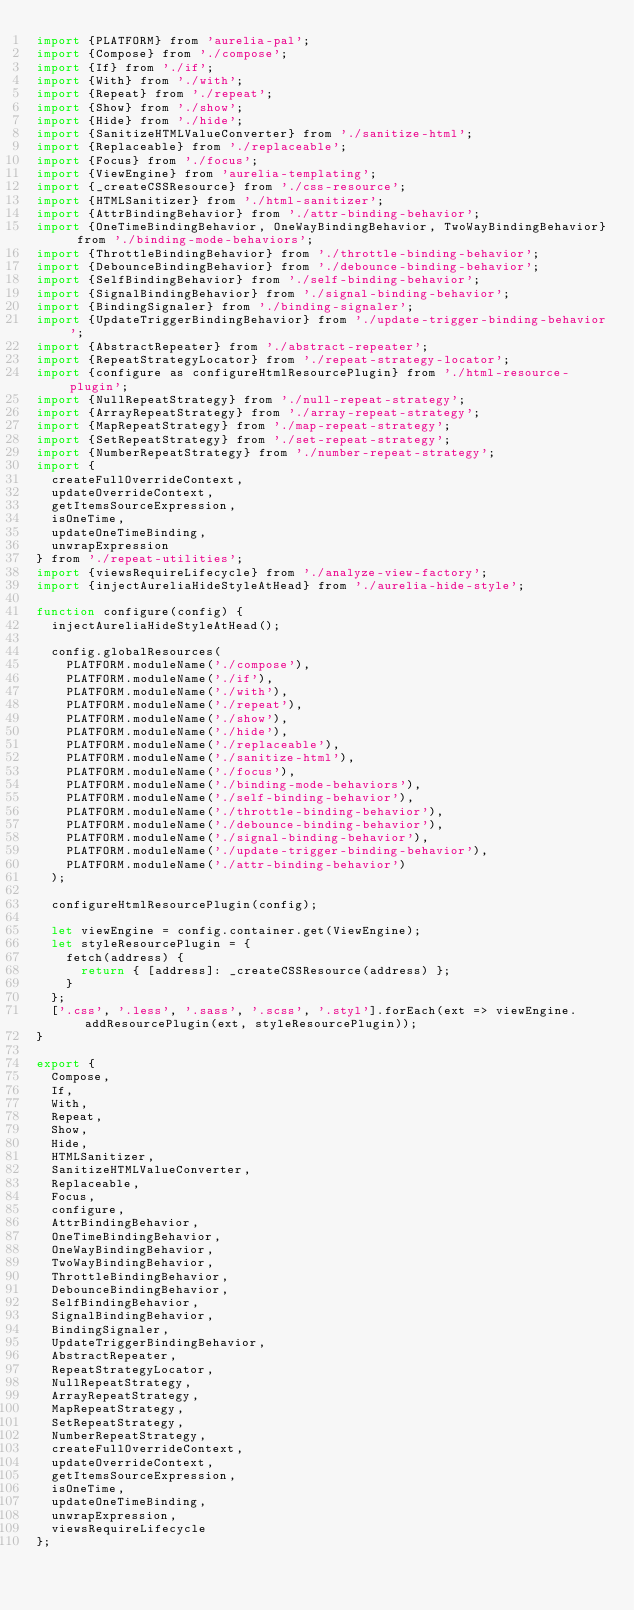Convert code to text. <code><loc_0><loc_0><loc_500><loc_500><_JavaScript_>import {PLATFORM} from 'aurelia-pal';
import {Compose} from './compose';
import {If} from './if';
import {With} from './with';
import {Repeat} from './repeat';
import {Show} from './show';
import {Hide} from './hide';
import {SanitizeHTMLValueConverter} from './sanitize-html';
import {Replaceable} from './replaceable';
import {Focus} from './focus';
import {ViewEngine} from 'aurelia-templating';
import {_createCSSResource} from './css-resource';
import {HTMLSanitizer} from './html-sanitizer';
import {AttrBindingBehavior} from './attr-binding-behavior';
import {OneTimeBindingBehavior, OneWayBindingBehavior, TwoWayBindingBehavior} from './binding-mode-behaviors';
import {ThrottleBindingBehavior} from './throttle-binding-behavior';
import {DebounceBindingBehavior} from './debounce-binding-behavior';
import {SelfBindingBehavior} from './self-binding-behavior';
import {SignalBindingBehavior} from './signal-binding-behavior';
import {BindingSignaler} from './binding-signaler';
import {UpdateTriggerBindingBehavior} from './update-trigger-binding-behavior';
import {AbstractRepeater} from './abstract-repeater';
import {RepeatStrategyLocator} from './repeat-strategy-locator';
import {configure as configureHtmlResourcePlugin} from './html-resource-plugin';
import {NullRepeatStrategy} from './null-repeat-strategy';
import {ArrayRepeatStrategy} from './array-repeat-strategy';
import {MapRepeatStrategy} from './map-repeat-strategy';
import {SetRepeatStrategy} from './set-repeat-strategy';
import {NumberRepeatStrategy} from './number-repeat-strategy';
import {
  createFullOverrideContext,
  updateOverrideContext,
  getItemsSourceExpression,
  isOneTime,
  updateOneTimeBinding,
  unwrapExpression
} from './repeat-utilities';
import {viewsRequireLifecycle} from './analyze-view-factory';
import {injectAureliaHideStyleAtHead} from './aurelia-hide-style';

function configure(config) {
  injectAureliaHideStyleAtHead();

  config.globalResources(
    PLATFORM.moduleName('./compose'),
    PLATFORM.moduleName('./if'),
    PLATFORM.moduleName('./with'),
    PLATFORM.moduleName('./repeat'),
    PLATFORM.moduleName('./show'),
    PLATFORM.moduleName('./hide'),
    PLATFORM.moduleName('./replaceable'),
    PLATFORM.moduleName('./sanitize-html'),
    PLATFORM.moduleName('./focus'),
    PLATFORM.moduleName('./binding-mode-behaviors'),
    PLATFORM.moduleName('./self-binding-behavior'),
    PLATFORM.moduleName('./throttle-binding-behavior'),
    PLATFORM.moduleName('./debounce-binding-behavior'),
    PLATFORM.moduleName('./signal-binding-behavior'),
    PLATFORM.moduleName('./update-trigger-binding-behavior'),
    PLATFORM.moduleName('./attr-binding-behavior')
  );

  configureHtmlResourcePlugin(config);

  let viewEngine = config.container.get(ViewEngine);
  let styleResourcePlugin = {
    fetch(address) {
      return { [address]: _createCSSResource(address) };
    }
  };
  ['.css', '.less', '.sass', '.scss', '.styl'].forEach(ext => viewEngine.addResourcePlugin(ext, styleResourcePlugin));
}

export {
  Compose,
  If,
  With,
  Repeat,
  Show,
  Hide,
  HTMLSanitizer,
  SanitizeHTMLValueConverter,
  Replaceable,
  Focus,
  configure,
  AttrBindingBehavior,
  OneTimeBindingBehavior,
  OneWayBindingBehavior,
  TwoWayBindingBehavior,
  ThrottleBindingBehavior,
  DebounceBindingBehavior,
  SelfBindingBehavior,
  SignalBindingBehavior,
  BindingSignaler,
  UpdateTriggerBindingBehavior,
  AbstractRepeater,
  RepeatStrategyLocator,
  NullRepeatStrategy,
  ArrayRepeatStrategy,
  MapRepeatStrategy,
  SetRepeatStrategy,
  NumberRepeatStrategy,
  createFullOverrideContext,
  updateOverrideContext,
  getItemsSourceExpression,
  isOneTime,
  updateOneTimeBinding,
  unwrapExpression,
  viewsRequireLifecycle
};
</code> 